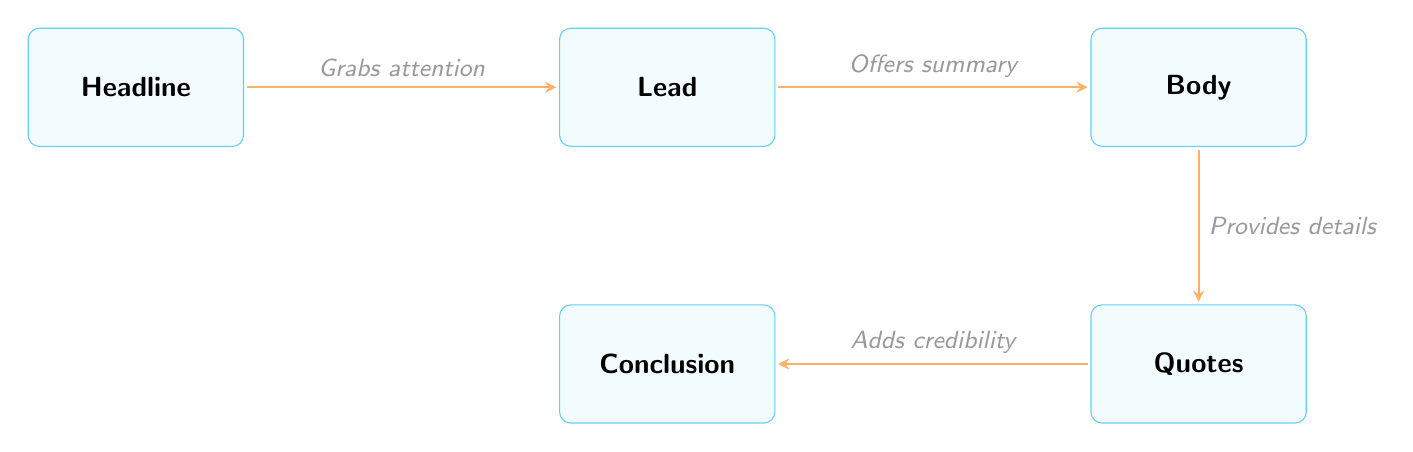What is the first component of a breaking news article? The diagram shows "Headline" as the first box on the left, indicating it is the starting component.
Answer: Headline How many main components are there in the structure of a breaking news article? Counting the boxes in the diagram, I see there are five components: Headline, Lead, Body, Quotes, and Conclusion.
Answer: 5 Which component follows the Lead? The diagram indicates that "Body" is directly to the right of "Lead," showing it comes next in the sequence.
Answer: Body What role does the headline play according to the diagram? The arrow flowing from "Headline" to "Lead" is labeled "Grabs attention," indicating its purpose in the article structure.
Answer: Grabs attention What do Quotes add to the article? The arrow from "Quotes" to "Conclusion" is labeled "Adds credibility," which reveals the function of Quotes in the context of the article.
Answer: Adds credibility What is the relationship between Body and Quotes? There is a flow from "Body" to "Quotes," labeled "Provides details," indicating that Quotes offer further detail about the Body.
Answer: Provides details What component is located below the Body? The diagram shows "Quotes" positioned directly beneath the "Body," indicating its placement in the article structure.
Answer: Quotes What does the Lead offer in the article? The arrow from "Lead" to "Body" states "Offers summary," showing the primary function of the Lead.
Answer: Offers summary What is the final component in the flow of the article? The last box in the diagram is "Conclusion," positioned below the Quotes, marking it as the final element in the structure.
Answer: Conclusion 